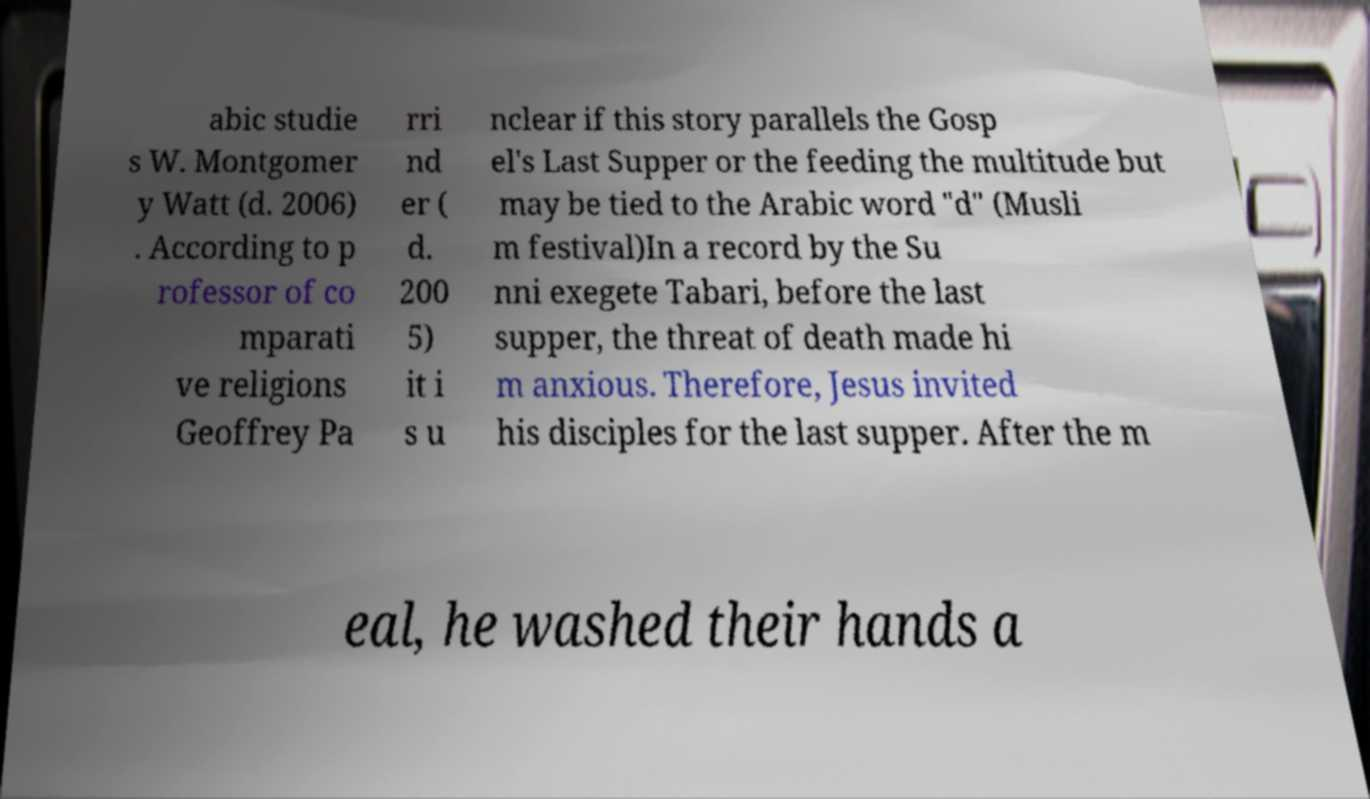Please identify and transcribe the text found in this image. abic studie s W. Montgomer y Watt (d. 2006) . According to p rofessor of co mparati ve religions Geoffrey Pa rri nd er ( d. 200 5) it i s u nclear if this story parallels the Gosp el's Last Supper or the feeding the multitude but may be tied to the Arabic word "d" (Musli m festival)In a record by the Su nni exegete Tabari, before the last supper, the threat of death made hi m anxious. Therefore, Jesus invited his disciples for the last supper. After the m eal, he washed their hands a 